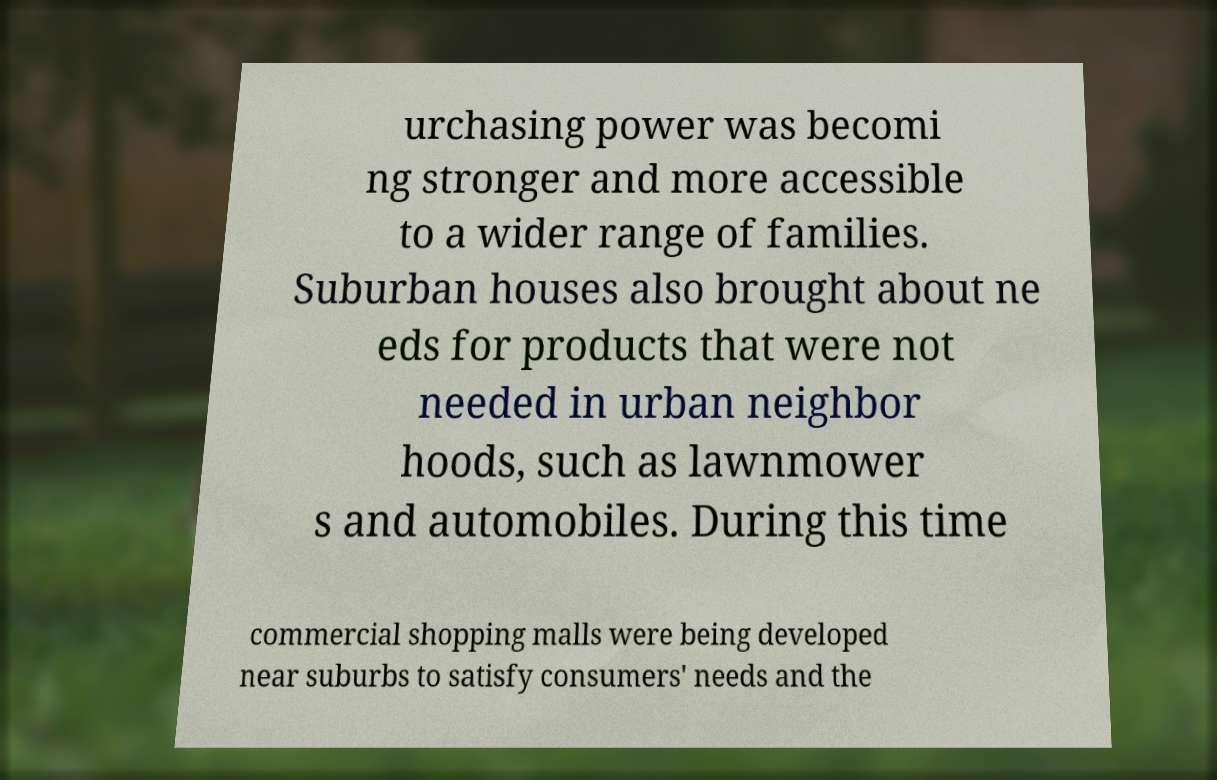Could you extract and type out the text from this image? urchasing power was becomi ng stronger and more accessible to a wider range of families. Suburban houses also brought about ne eds for products that were not needed in urban neighbor hoods, such as lawnmower s and automobiles. During this time commercial shopping malls were being developed near suburbs to satisfy consumers' needs and the 